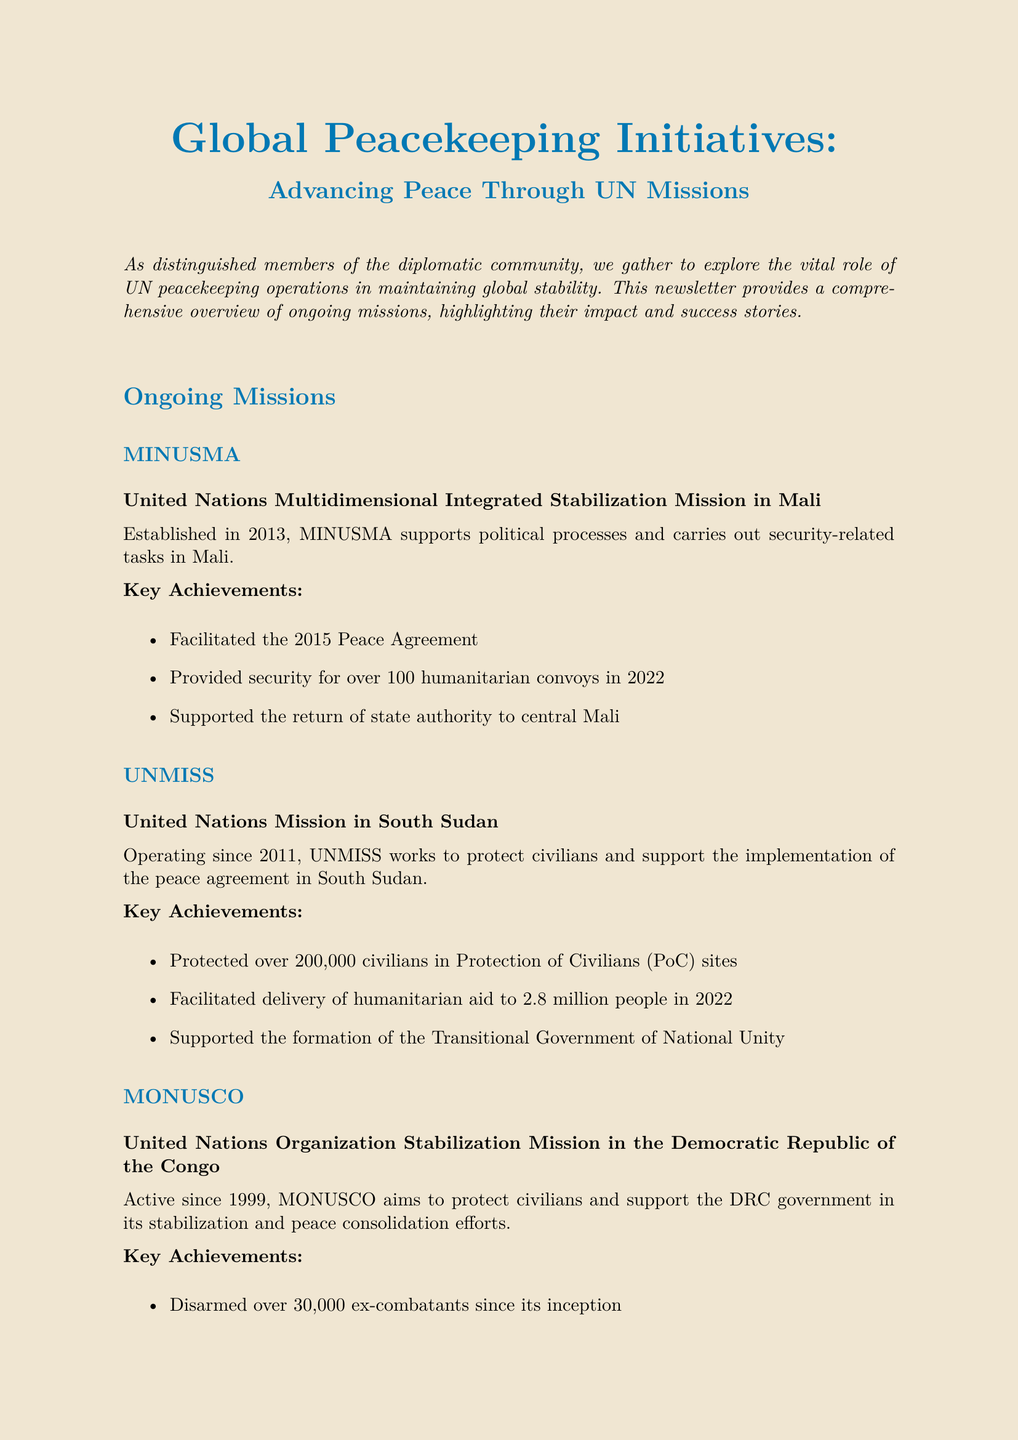What is the title of the newsletter? The title of the newsletter is stated at the beginning of the document.
Answer: Global Peacekeeping Initiatives: Advancing Peace Through UN Missions How many ongoing peacekeeping missions are currently reported? The infographic section provides the number of current peacekeeping operations.
Answer: 12 Which mission aims to protect civilians in South Sudan? Each mission is described in the ongoing missions section, specifically focusing on their objectives.
Answer: UNMISS What percentage of female peacekeepers is reported? The infographic includes a specific percentage regarding female peacekeepers.
Answer: 6.6% What major achievement is associated with MINUSMA? The key achievements listed for each mission highlight their significant contributions.
Answer: Facilitated the 2015 Peace Agreement What is the annual budget for UN peacekeeping for 2022-2023? The budget information is provided in the infographic section of the newsletter.
Answer: $6.45 billion Which peacekeeping mission played a crucial role in Liberia's transition? The success story section details the major accomplishments of a specific mission.
Answer: UNMIL What challenge involves increasing women’s participation in peacekeeping? The challenges and opportunities section outlines various issues that peacekeeping operations face.
Answer: Increasing women's participation in peacekeeping and peacebuilding processes 